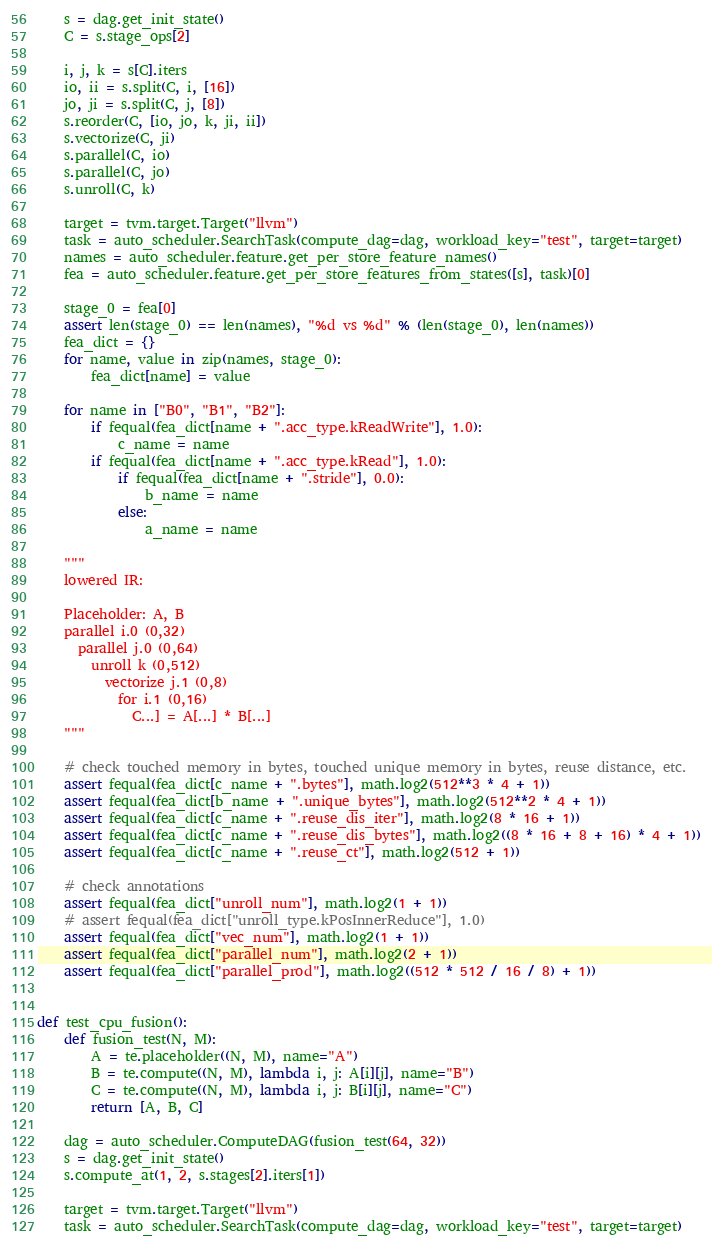Convert code to text. <code><loc_0><loc_0><loc_500><loc_500><_Python_>    s = dag.get_init_state()
    C = s.stage_ops[2]

    i, j, k = s[C].iters
    io, ii = s.split(C, i, [16])
    jo, ji = s.split(C, j, [8])
    s.reorder(C, [io, jo, k, ji, ii])
    s.vectorize(C, ji)
    s.parallel(C, io)
    s.parallel(C, jo)
    s.unroll(C, k)

    target = tvm.target.Target("llvm")
    task = auto_scheduler.SearchTask(compute_dag=dag, workload_key="test", target=target)
    names = auto_scheduler.feature.get_per_store_feature_names()
    fea = auto_scheduler.feature.get_per_store_features_from_states([s], task)[0]

    stage_0 = fea[0]
    assert len(stage_0) == len(names), "%d vs %d" % (len(stage_0), len(names))
    fea_dict = {}
    for name, value in zip(names, stage_0):
        fea_dict[name] = value

    for name in ["B0", "B1", "B2"]:
        if fequal(fea_dict[name + ".acc_type.kReadWrite"], 1.0):
            c_name = name
        if fequal(fea_dict[name + ".acc_type.kRead"], 1.0):
            if fequal(fea_dict[name + ".stride"], 0.0):
                b_name = name
            else:
                a_name = name

    """
    lowered IR:
    
    Placeholder: A, B
    parallel i.0 (0,32)
      parallel j.0 (0,64)
        unroll k (0,512)
          vectorize j.1 (0,8)
            for i.1 (0,16)
              C...] = A[...] * B[...]
    """

    # check touched memory in bytes, touched unique memory in bytes, reuse distance, etc.
    assert fequal(fea_dict[c_name + ".bytes"], math.log2(512**3 * 4 + 1))
    assert fequal(fea_dict[b_name + ".unique_bytes"], math.log2(512**2 * 4 + 1))
    assert fequal(fea_dict[c_name + ".reuse_dis_iter"], math.log2(8 * 16 + 1))
    assert fequal(fea_dict[c_name + ".reuse_dis_bytes"], math.log2((8 * 16 + 8 + 16) * 4 + 1))
    assert fequal(fea_dict[c_name + ".reuse_ct"], math.log2(512 + 1))

    # check annotations
    assert fequal(fea_dict["unroll_num"], math.log2(1 + 1))
    # assert fequal(fea_dict["unroll_type.kPosInnerReduce"], 1.0)
    assert fequal(fea_dict["vec_num"], math.log2(1 + 1))
    assert fequal(fea_dict["parallel_num"], math.log2(2 + 1))
    assert fequal(fea_dict["parallel_prod"], math.log2((512 * 512 / 16 / 8) + 1))


def test_cpu_fusion():
    def fusion_test(N, M):
        A = te.placeholder((N, M), name="A")
        B = te.compute((N, M), lambda i, j: A[i][j], name="B")
        C = te.compute((N, M), lambda i, j: B[i][j], name="C")
        return [A, B, C]

    dag = auto_scheduler.ComputeDAG(fusion_test(64, 32))
    s = dag.get_init_state()
    s.compute_at(1, 2, s.stages[2].iters[1])

    target = tvm.target.Target("llvm")
    task = auto_scheduler.SearchTask(compute_dag=dag, workload_key="test", target=target)</code> 